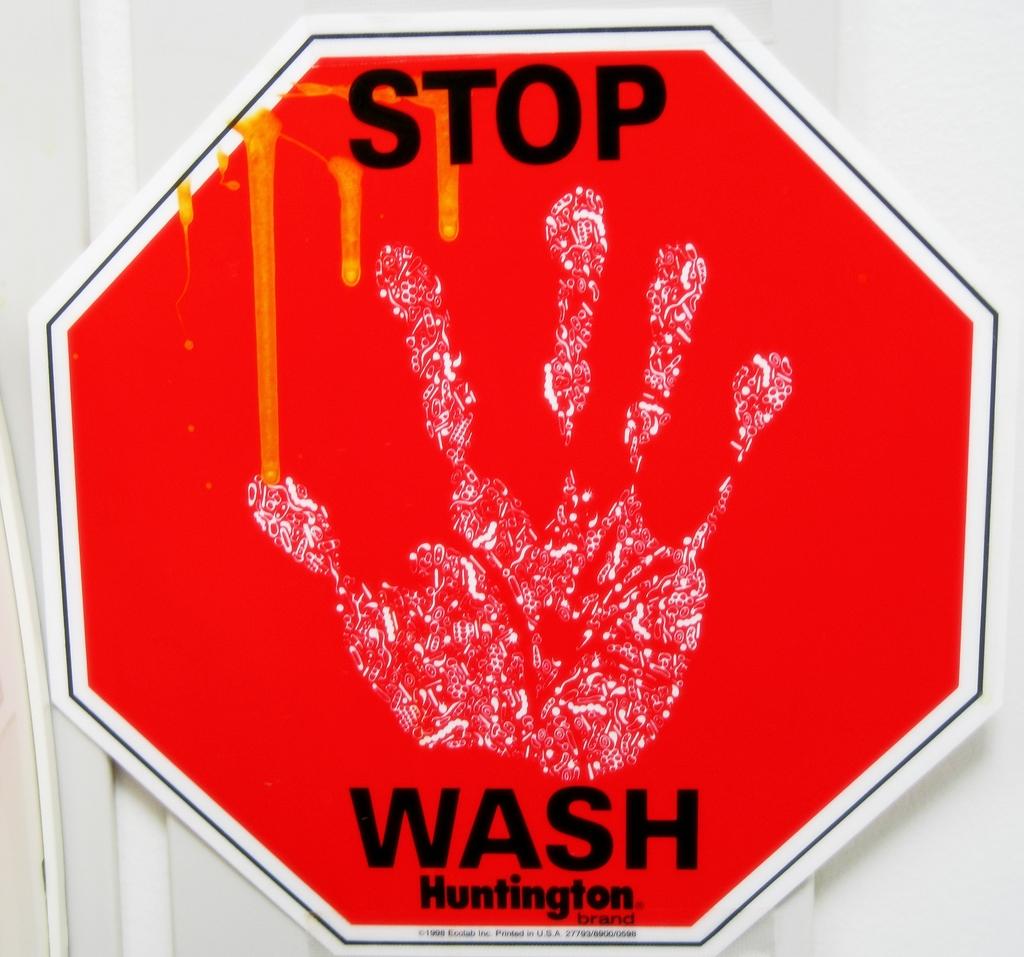Does the hand represent dirty hands that need to be washed?
Your answer should be very brief. Yes. What needs to be stopped?
Your answer should be compact. Wash. 